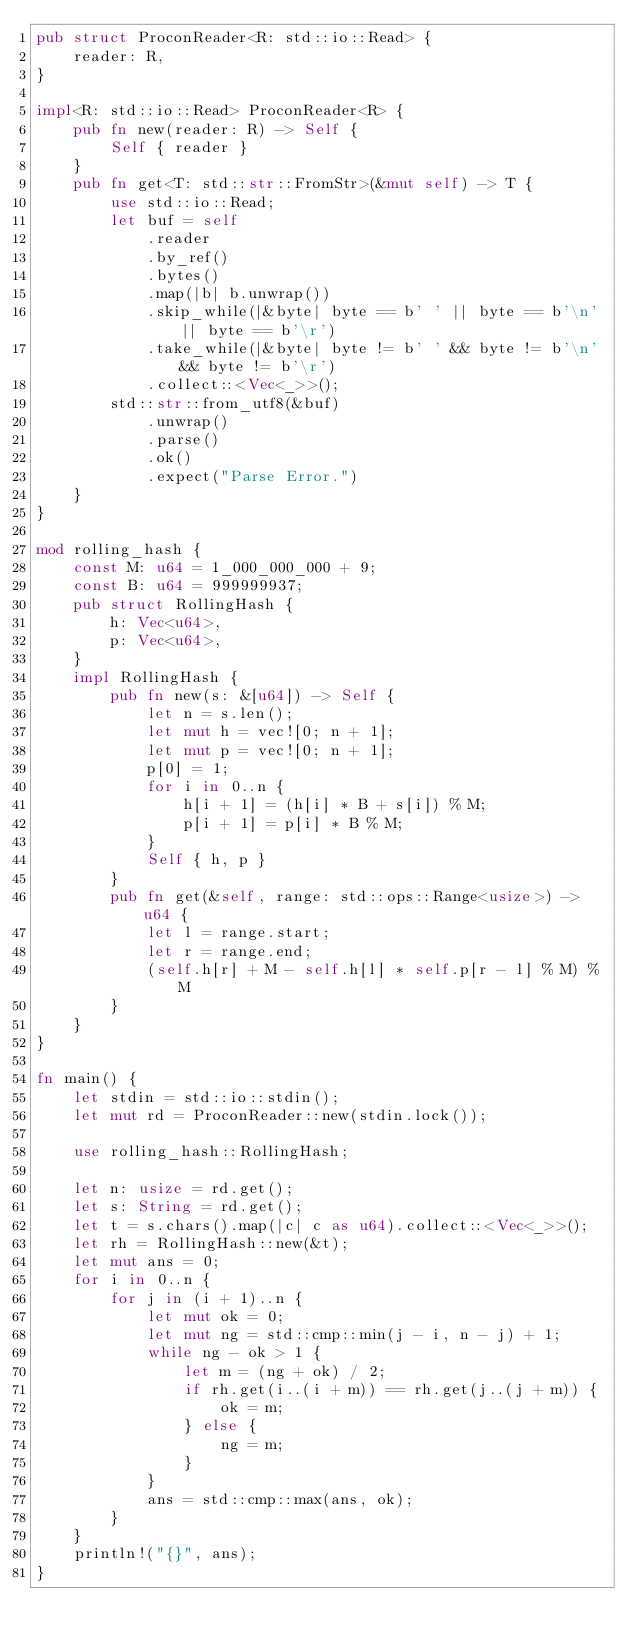Convert code to text. <code><loc_0><loc_0><loc_500><loc_500><_Rust_>pub struct ProconReader<R: std::io::Read> {
    reader: R,
}

impl<R: std::io::Read> ProconReader<R> {
    pub fn new(reader: R) -> Self {
        Self { reader }
    }
    pub fn get<T: std::str::FromStr>(&mut self) -> T {
        use std::io::Read;
        let buf = self
            .reader
            .by_ref()
            .bytes()
            .map(|b| b.unwrap())
            .skip_while(|&byte| byte == b' ' || byte == b'\n' || byte == b'\r')
            .take_while(|&byte| byte != b' ' && byte != b'\n' && byte != b'\r')
            .collect::<Vec<_>>();
        std::str::from_utf8(&buf)
            .unwrap()
            .parse()
            .ok()
            .expect("Parse Error.")
    }
}

mod rolling_hash {
    const M: u64 = 1_000_000_000 + 9;
    const B: u64 = 999999937;
    pub struct RollingHash {
        h: Vec<u64>,
        p: Vec<u64>,
    }
    impl RollingHash {
        pub fn new(s: &[u64]) -> Self {
            let n = s.len();
            let mut h = vec![0; n + 1];
            let mut p = vec![0; n + 1];
            p[0] = 1;
            for i in 0..n {
                h[i + 1] = (h[i] * B + s[i]) % M;
                p[i + 1] = p[i] * B % M;
            }
            Self { h, p }
        }
        pub fn get(&self, range: std::ops::Range<usize>) -> u64 {
            let l = range.start;
            let r = range.end;
            (self.h[r] + M - self.h[l] * self.p[r - l] % M) % M
        }
    }
}

fn main() {
    let stdin = std::io::stdin();
    let mut rd = ProconReader::new(stdin.lock());

    use rolling_hash::RollingHash;

    let n: usize = rd.get();
    let s: String = rd.get();
    let t = s.chars().map(|c| c as u64).collect::<Vec<_>>();
    let rh = RollingHash::new(&t);
    let mut ans = 0;
    for i in 0..n {
        for j in (i + 1)..n {
            let mut ok = 0;
            let mut ng = std::cmp::min(j - i, n - j) + 1;
            while ng - ok > 1 {
                let m = (ng + ok) / 2;
                if rh.get(i..(i + m)) == rh.get(j..(j + m)) {
                    ok = m;
                } else {
                    ng = m;
                }
            }
            ans = std::cmp::max(ans, ok);
        }
    }
    println!("{}", ans);
}</code> 